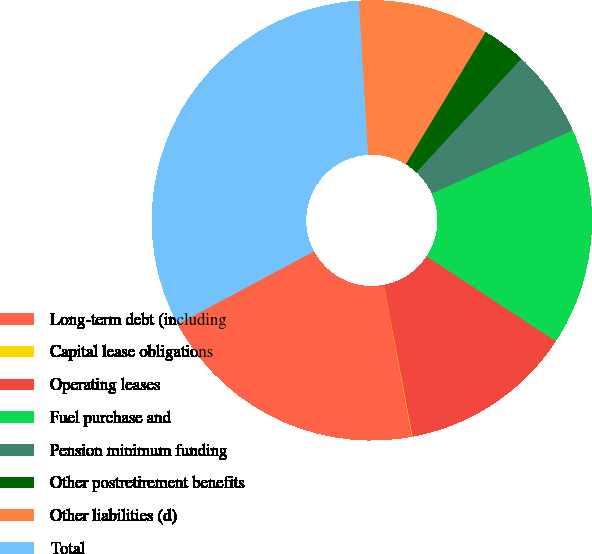Convert chart. <chart><loc_0><loc_0><loc_500><loc_500><pie_chart><fcel>Long-term debt (including<fcel>Capital lease obligations<fcel>Operating leases<fcel>Fuel purchase and<fcel>Pension minimum funding<fcel>Other postretirement benefits<fcel>Other liabilities (d)<fcel>Total<nl><fcel>20.11%<fcel>0.05%<fcel>12.78%<fcel>15.96%<fcel>6.41%<fcel>3.23%<fcel>9.59%<fcel>31.87%<nl></chart> 